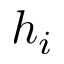Convert formula to latex. <formula><loc_0><loc_0><loc_500><loc_500>h _ { i }</formula> 